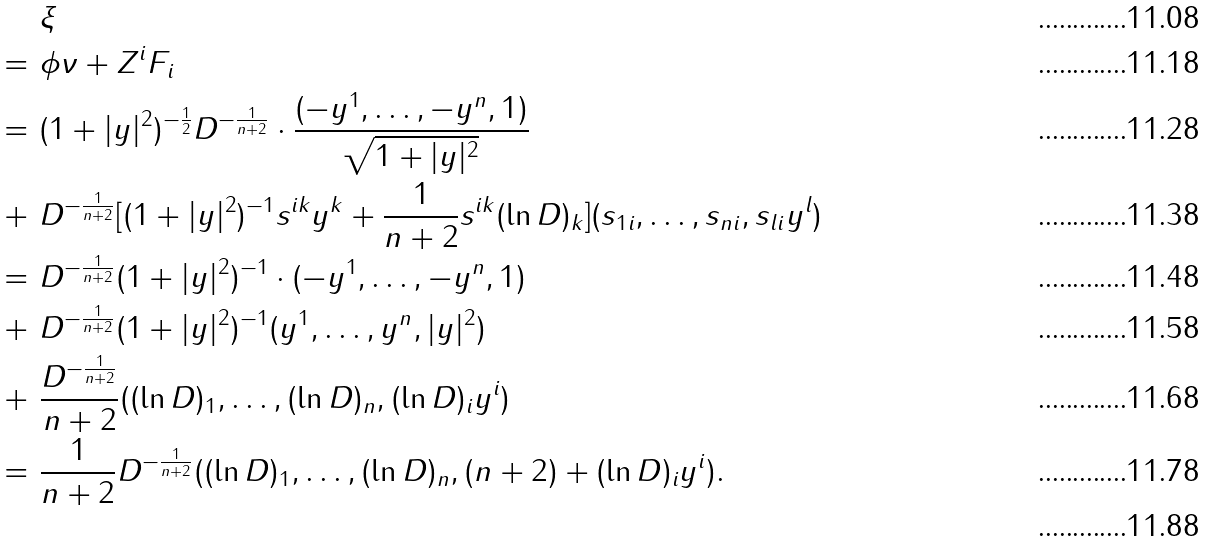<formula> <loc_0><loc_0><loc_500><loc_500>& \xi \\ = \ & \phi \nu + Z ^ { i } F _ { i } \\ = \ & ( 1 + | y | ^ { 2 } ) ^ { - \frac { 1 } { 2 } } D ^ { - \frac { 1 } { n + 2 } } \cdot \frac { ( - y ^ { 1 } , \dots , - y ^ { n } , 1 ) } { \sqrt { 1 + | y | ^ { 2 } } } \\ + \ & D ^ { - \frac { 1 } { n + 2 } } [ ( 1 + | y | ^ { 2 } ) ^ { - 1 } s ^ { i k } y ^ { k } + \frac { 1 } { n + 2 } s ^ { i k } ( \ln D ) _ { k } ] ( s _ { 1 i } , \dots , s _ { n i } , s _ { l i } y ^ { l } ) \\ = \ & D ^ { - \frac { 1 } { n + 2 } } ( 1 + | y | ^ { 2 } ) ^ { - 1 } \cdot ( - y ^ { 1 } , \dots , - y ^ { n } , 1 ) \\ + \ & D ^ { - \frac { 1 } { n + 2 } } ( 1 + | y | ^ { 2 } ) ^ { - 1 } ( y ^ { 1 } , \dots , y ^ { n } , | y | ^ { 2 } ) \\ + \ & \frac { D ^ { - \frac { 1 } { n + 2 } } } { n + 2 } ( ( \ln D ) _ { 1 } , \dots , ( \ln D ) _ { n } , ( \ln D ) _ { i } y ^ { i } ) \\ = \ & \frac { 1 } { n + 2 } D ^ { - \frac { 1 } { n + 2 } } ( ( \ln D ) _ { 1 } , \dots , ( \ln D ) _ { n } , ( n + 2 ) + ( \ln D ) _ { i } y ^ { i } ) . \\</formula> 